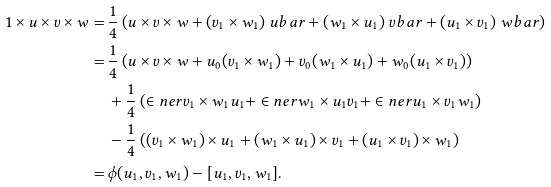Convert formula to latex. <formula><loc_0><loc_0><loc_500><loc_500>1 \times u \times v \times w = & \, \frac { 1 } { 4 } \left ( u \times v \times w + ( v _ { 1 } \times w _ { 1 } ) \ u b a r + ( w _ { 1 } \times u _ { 1 } ) \ v b a r + ( u _ { 1 } \times v _ { 1 } ) \ w b a r \right ) \\ = & \, \frac { 1 } { 4 } \left ( u \times v \times w + u _ { 0 } ( v _ { 1 } \times w _ { 1 } ) + v _ { 0 } ( w _ { 1 } \times u _ { 1 } ) + w _ { 0 } ( u _ { 1 } \times v _ { 1 } ) \right ) \\ & \, + \frac { 1 } { 4 } \left ( \in n e r { v _ { 1 } \times w _ { 1 } } { u _ { 1 } } + \in n e r { w _ { 1 } \times u _ { 1 } } { v _ { 1 } } + \in n e r { u _ { 1 } \times v _ { 1 } } { w _ { 1 } } \right ) \\ & \, - \frac { 1 } { 4 } \left ( ( v _ { 1 } \times w _ { 1 } ) \times u _ { 1 } + ( w _ { 1 } \times u _ { 1 } ) \times v _ { 1 } + ( u _ { 1 } \times v _ { 1 } ) \times w _ { 1 } \right ) \\ = & \, \phi ( u _ { 1 } , v _ { 1 } , w _ { 1 } ) - [ u _ { 1 } , v _ { 1 } , w _ { 1 } ] .</formula> 